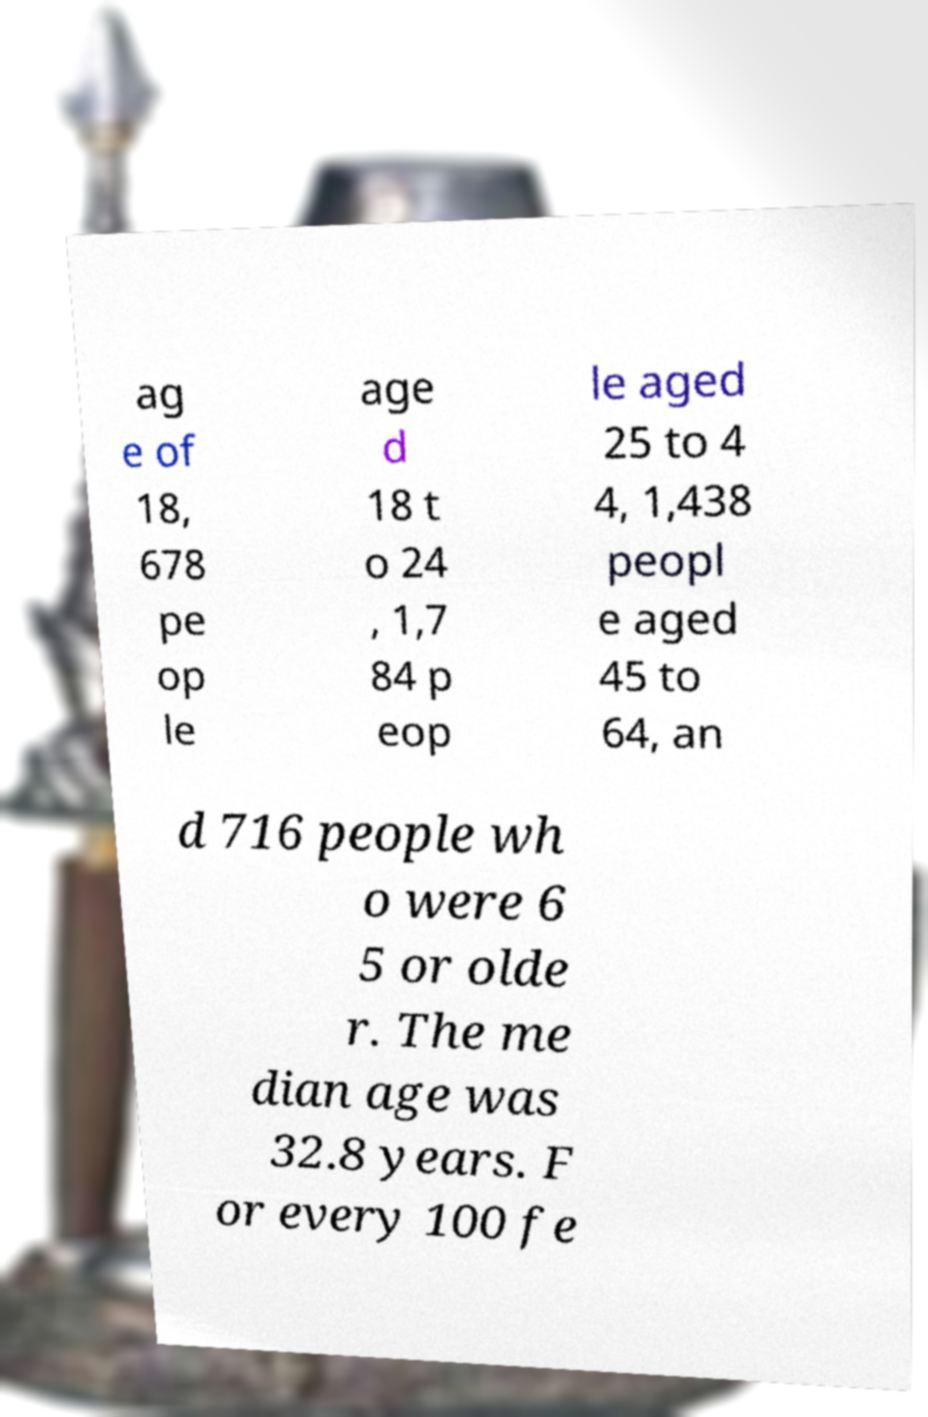Can you accurately transcribe the text from the provided image for me? ag e of 18, 678 pe op le age d 18 t o 24 , 1,7 84 p eop le aged 25 to 4 4, 1,438 peopl e aged 45 to 64, an d 716 people wh o were 6 5 or olde r. The me dian age was 32.8 years. F or every 100 fe 